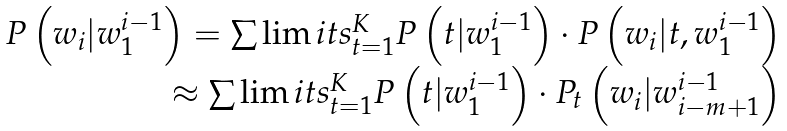Convert formula to latex. <formula><loc_0><loc_0><loc_500><loc_500>\begin{array} { r } P \left ( w _ { i } | w _ { 1 } ^ { i - 1 } \right ) = \sum \lim i t s _ { t = 1 } ^ { K } P \left ( t | w _ { 1 } ^ { i - 1 } \right ) \cdot P \left ( w _ { i } | t , w _ { 1 } ^ { i - 1 } \right ) \\ \approx \sum \lim i t s _ { t = 1 } ^ { K } P \left ( t | w _ { 1 } ^ { i - 1 } \right ) \cdot P _ { t } \left ( w _ { i } | w _ { i - m + 1 } ^ { i - 1 } \right ) \end{array}</formula> 